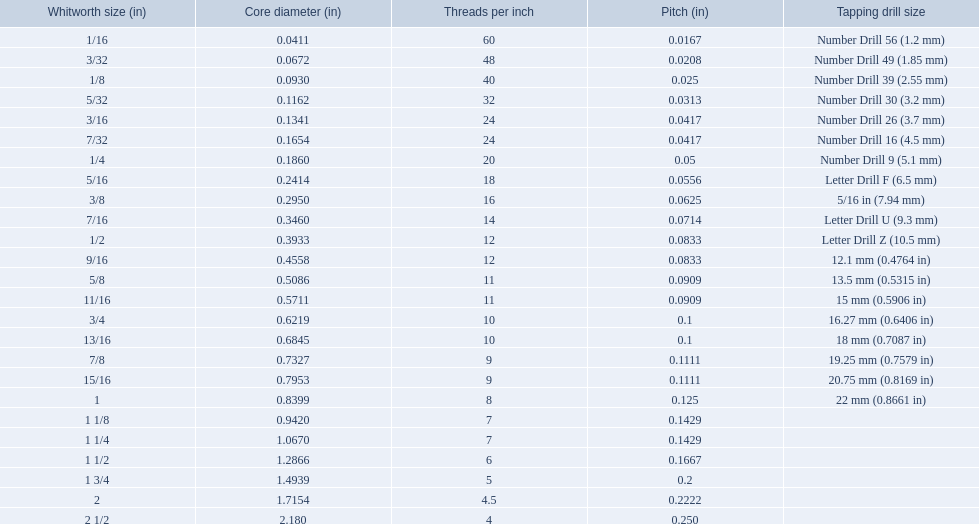What encompasses all whitworth proportions? 1/16, 3/32, 1/8, 5/32, 3/16, 7/32, 1/4, 5/16, 3/8, 7/16, 1/2, 9/16, 5/8, 11/16, 3/4, 13/16, 7/8, 15/16, 1, 1 1/8, 1 1/4, 1 1/2, 1 3/4, 2, 2 1/2. What are the threads per inch of these proportions? 60, 48, 40, 32, 24, 24, 20, 18, 16, 14, 12, 12, 11, 11, 10, 10, 9, 9, 8, 7, 7, 6, 5, 4.5, 4. From these, which are 5? 5. What whitworth proportion has this threads per inch? 1 3/4. 